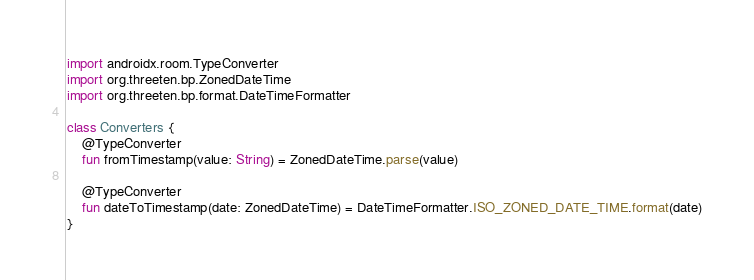<code> <loc_0><loc_0><loc_500><loc_500><_Kotlin_>import androidx.room.TypeConverter
import org.threeten.bp.ZonedDateTime
import org.threeten.bp.format.DateTimeFormatter

class Converters {
    @TypeConverter
    fun fromTimestamp(value: String) = ZonedDateTime.parse(value)

    @TypeConverter
    fun dateToTimestamp(date: ZonedDateTime) = DateTimeFormatter.ISO_ZONED_DATE_TIME.format(date)
}
</code> 